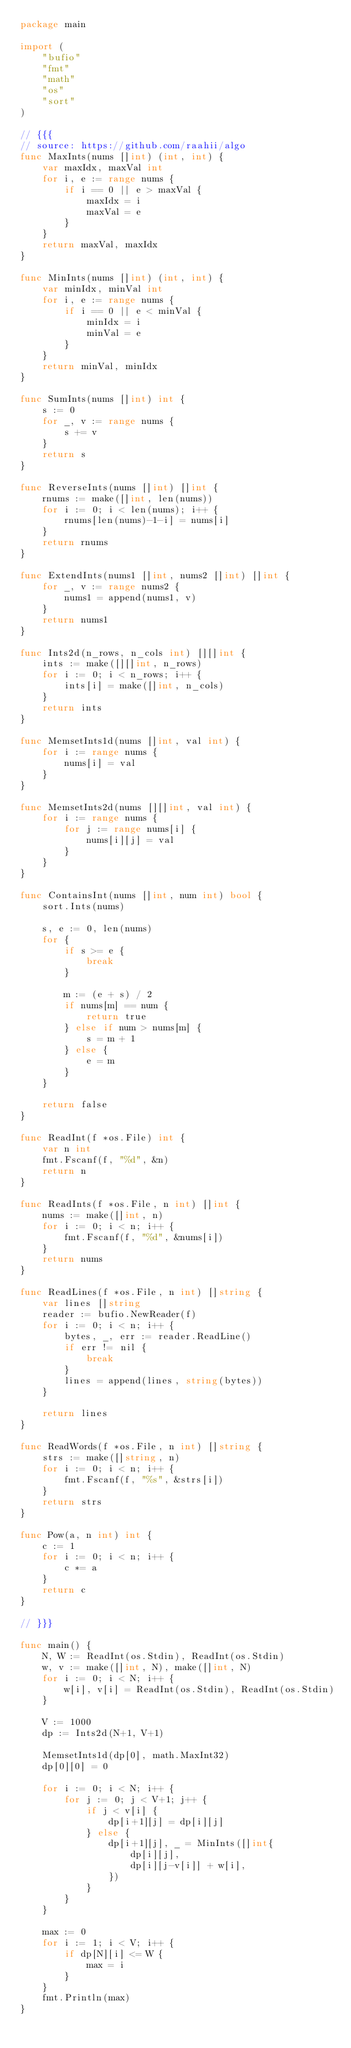Convert code to text. <code><loc_0><loc_0><loc_500><loc_500><_Go_>package main

import (
	"bufio"
	"fmt"
	"math"
	"os"
	"sort"
)

// {{{
// source: https://github.com/raahii/algo
func MaxInts(nums []int) (int, int) {
	var maxIdx, maxVal int
	for i, e := range nums {
		if i == 0 || e > maxVal {
			maxIdx = i
			maxVal = e
		}
	}
	return maxVal, maxIdx
}

func MinInts(nums []int) (int, int) {
	var minIdx, minVal int
	for i, e := range nums {
		if i == 0 || e < minVal {
			minIdx = i
			minVal = e
		}
	}
	return minVal, minIdx
}

func SumInts(nums []int) int {
	s := 0
	for _, v := range nums {
		s += v
	}
	return s
}

func ReverseInts(nums []int) []int {
	rnums := make([]int, len(nums))
	for i := 0; i < len(nums); i++ {
		rnums[len(nums)-1-i] = nums[i]
	}
	return rnums
}

func ExtendInts(nums1 []int, nums2 []int) []int {
	for _, v := range nums2 {
		nums1 = append(nums1, v)
	}
	return nums1
}

func Ints2d(n_rows, n_cols int) [][]int {
	ints := make([][]int, n_rows)
	for i := 0; i < n_rows; i++ {
		ints[i] = make([]int, n_cols)
	}
	return ints
}

func MemsetInts1d(nums []int, val int) {
	for i := range nums {
		nums[i] = val
	}
}

func MemsetInts2d(nums [][]int, val int) {
	for i := range nums {
		for j := range nums[i] {
			nums[i][j] = val
		}
	}
}

func ContainsInt(nums []int, num int) bool {
	sort.Ints(nums)

	s, e := 0, len(nums)
	for {
		if s >= e {
			break
		}

		m := (e + s) / 2
		if nums[m] == num {
			return true
		} else if num > nums[m] {
			s = m + 1
		} else {
			e = m
		}
	}

	return false
}

func ReadInt(f *os.File) int {
	var n int
	fmt.Fscanf(f, "%d", &n)
	return n
}

func ReadInts(f *os.File, n int) []int {
	nums := make([]int, n)
	for i := 0; i < n; i++ {
		fmt.Fscanf(f, "%d", &nums[i])
	}
	return nums
}

func ReadLines(f *os.File, n int) []string {
	var lines []string
	reader := bufio.NewReader(f)
	for i := 0; i < n; i++ {
		bytes, _, err := reader.ReadLine()
		if err != nil {
			break
		}
		lines = append(lines, string(bytes))
	}

	return lines
}

func ReadWords(f *os.File, n int) []string {
	strs := make([]string, n)
	for i := 0; i < n; i++ {
		fmt.Fscanf(f, "%s", &strs[i])
	}
	return strs
}

func Pow(a, n int) int {
	c := 1
	for i := 0; i < n; i++ {
		c *= a
	}
	return c
}

// }}}

func main() {
	N, W := ReadInt(os.Stdin), ReadInt(os.Stdin)
	w, v := make([]int, N), make([]int, N)
	for i := 0; i < N; i++ {
		w[i], v[i] = ReadInt(os.Stdin), ReadInt(os.Stdin)
	}

	V := 1000
	dp := Ints2d(N+1, V+1)

	MemsetInts1d(dp[0], math.MaxInt32)
	dp[0][0] = 0

	for i := 0; i < N; i++ {
		for j := 0; j < V+1; j++ {
			if j < v[i] {
				dp[i+1][j] = dp[i][j]
			} else {
				dp[i+1][j], _ = MinInts([]int{
					dp[i][j],
					dp[i][j-v[i]] + w[i],
				})
			}
		}
	}

	max := 0
	for i := 1; i < V; i++ {
		if dp[N][i] <= W {
			max = i
		}
	}
	fmt.Println(max)
}</code> 